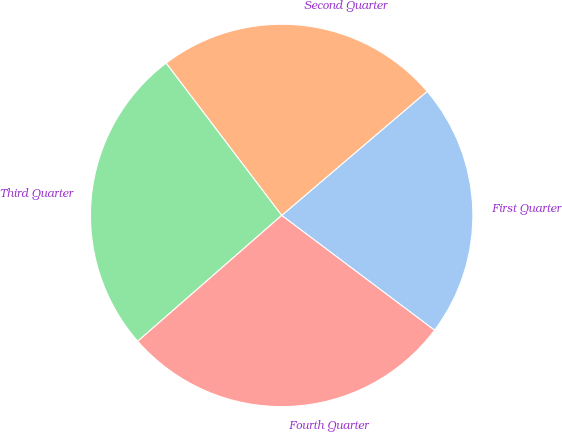<chart> <loc_0><loc_0><loc_500><loc_500><pie_chart><fcel>First Quarter<fcel>Second Quarter<fcel>Third Quarter<fcel>Fourth Quarter<nl><fcel>21.49%<fcel>24.09%<fcel>26.1%<fcel>28.31%<nl></chart> 